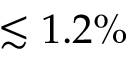Convert formula to latex. <formula><loc_0><loc_0><loc_500><loc_500>\lesssim 1 . 2 \%</formula> 